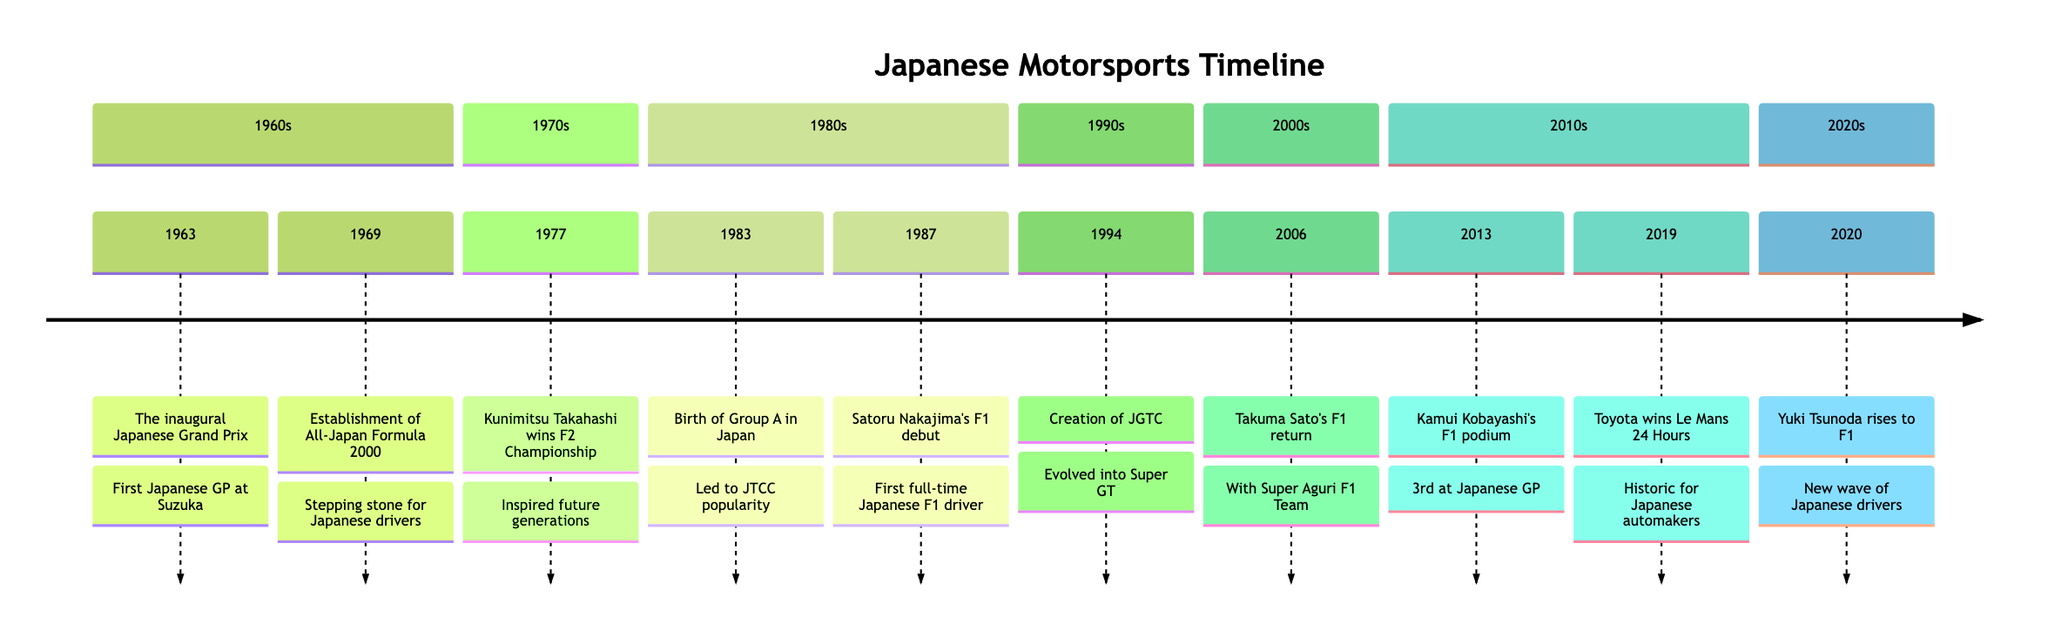What year was the inaugural Japanese Grand Prix? The information in the timeline indicates that the inaugural Japanese Grand Prix occurred in 1963. This event is clearly marked with its year and title, making it easy to identify.
Answer: 1963 Who won the Formula Two Championship in 1977? The timeline shows that Kunimitsu Takahashi won the Formula Two Championship in 1977. This is a key event highlighted in the timeline, providing specific details about the driver involved.
Answer: Kunimitsu Takahashi What event occurred in 1987? According to the timeline, in 1987, Satoru Nakajima made his debut in Formula 1, marking a significant moment in Japan's motorsport history. The specific year and event are clearly outlined in the diagram.
Answer: Satoru Nakajima's debut in Formula 1 How many championships/events are listed from the 1990s? The timeline provides information from the 1990s, specifically one event: the creation of JGTC in 1994. By counting the entries in that decade section, we can confirm that there is one event.
Answer: 1 What was established in 1994? The timeline states that in 1994, the Japan Grand Touring Championship (JGTC) was created. This clear reference in the timeline directly answers the question about what was established that year.
Answer: JGTC Which driver returned to Formula 1 with Super Aguri in 2006? The timeline indicates that Takuma Sato returned to Formula 1 with the Super Aguri F1 Team in 2006, which is a significant note for Japanese drivers in F1. This is directly stated in the description for that year.
Answer: Takuma Sato In which section of the timeline does the event related to Toyota winning the 24 Hours of Le Mans appear? The event where Toyota wins the 24 Hours of Le Mans in 2019 is located in the 2010s section of the timeline. By looking at the organizational structure of the timeline, we can identify which section each event falls under.
Answer: 2010s What transition in racing class took place with the establishment of Group A in 1983? The timeline notes that the establishment of Group A in 1983 led to the popularity of the Japan Touring Car Championship (JTCC), outlining an important transition in racing classes during that time.
Answer: JTCC popularity 